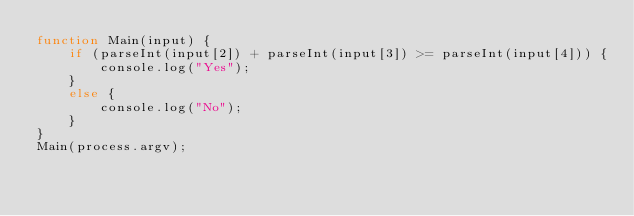<code> <loc_0><loc_0><loc_500><loc_500><_JavaScript_>function Main(input) {
    if (parseInt(input[2]) + parseInt(input[3]) >= parseInt(input[4])) {
        console.log("Yes");
    }
    else {
        console.log("No");
    }
}
Main(process.argv);
</code> 